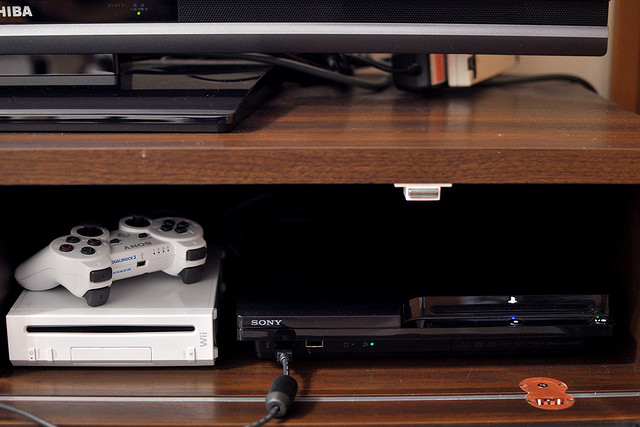Please extract the text content from this image. SONY HIBA 